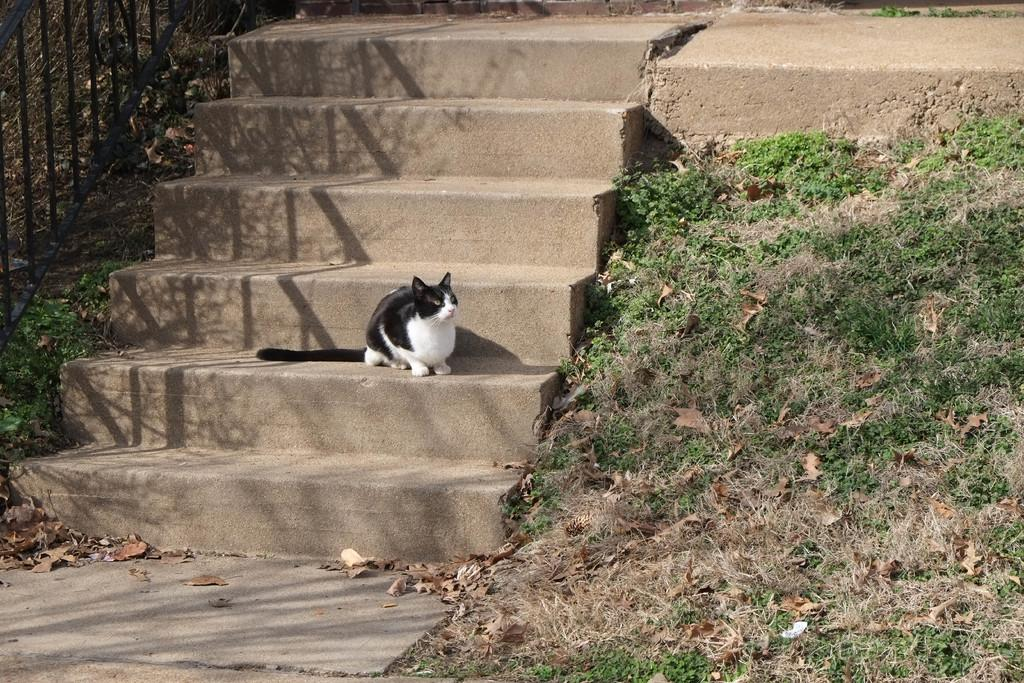Where was the image taken? The image was clicked outside. What can be seen on the left side of the image? There is iron railing on the left side of the image. What architectural feature is in the middle of the image? There are stairs in the middle of the image. What animal is present on the stairs? A cat is present on the stairs. What type of vegetation is on the right side of the image? There is grass on the right side of the image. What type of plate is being used by the cat to slide down the stairs in the image? There is no plate present in the image, and the cat is not sliding down the stairs. 